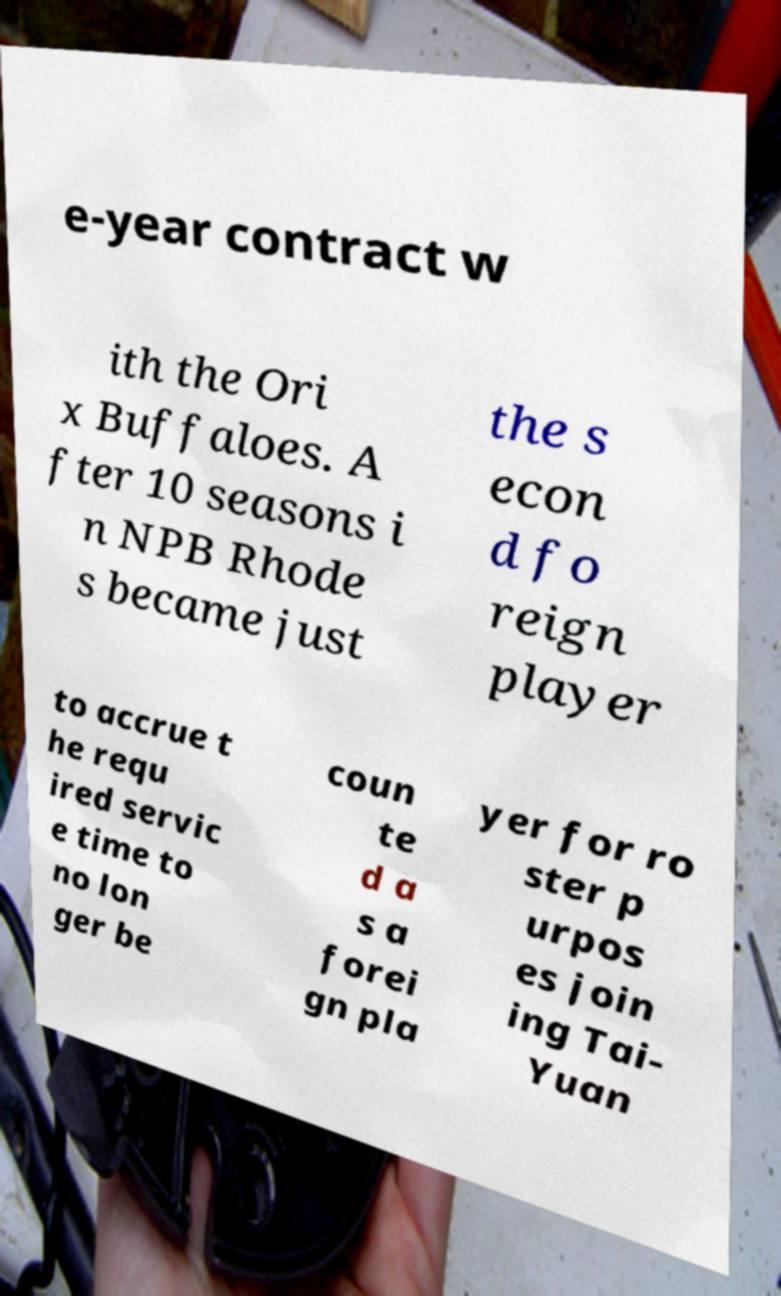Please read and relay the text visible in this image. What does it say? e-year contract w ith the Ori x Buffaloes. A fter 10 seasons i n NPB Rhode s became just the s econ d fo reign player to accrue t he requ ired servic e time to no lon ger be coun te d a s a forei gn pla yer for ro ster p urpos es join ing Tai- Yuan 